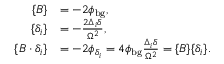Convert formula to latex. <formula><loc_0><loc_0><loc_500><loc_500>\begin{array} { r l } { \{ B \} } & { = - 2 \phi _ { b g } , } \\ { \{ \delta _ { i } \} } & { = - \frac { 2 \Delta _ { i } \delta } { \Omega ^ { 2 } } , } \\ { \{ B \cdot \delta _ { i } \} } & { = - 2 \phi _ { \delta _ { i } } = 4 \phi _ { b g } \frac { \Delta _ { i } \delta } { \Omega ^ { 2 } } = \{ B \} \{ \delta _ { i } \} . } \end{array}</formula> 